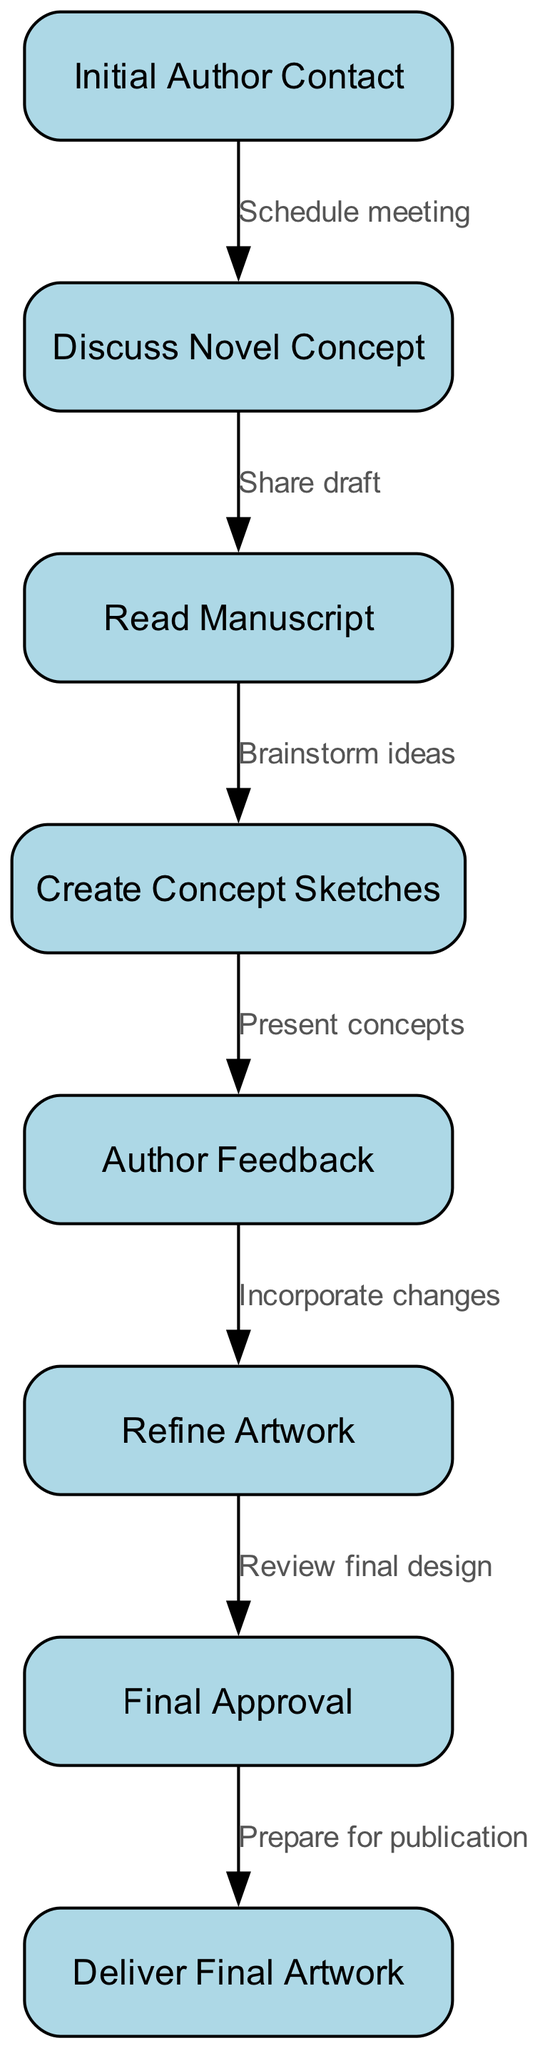What is the first step in the collaboration process? The first step in the collaboration process, as indicated by the initial node in the diagram, is "Initial Author Contact." This node does not have any preceding connections, confirming it as the starting point.
Answer: Initial Author Contact How many nodes are present in the diagram? By counting the distinct nodes listed in the data, we find there are 8 nodes illustrated in the collaboration process. Each one represents a unique step in the flowchart.
Answer: 8 What is the relationship between "Discuss Novel Concept" and "Read Manuscript"? The relationship is established by the directed edge from "Discuss Novel Concept" to "Read Manuscript," labeled as "Share draft." This indicates that the flow progresses from the discussion to sharing the manuscript for reading.
Answer: Share draft What action follows "Final Approval" in the process? The action that follows "Final Approval," as per the connection in the flowchart, is "Deliver Final Artwork." This sequential arrangement indicates the next step once approval has been secured.
Answer: Deliver Final Artwork Which two steps directly involve feedback? The two steps that involve feedback are "Author Feedback" and "Refine Artwork." The "Author Feedback" node solicits feedback, and "Refine Artwork" incorporates that feedback into revisions. Thus, both steps are interconnected through the feedback mechanism.
Answer: Author Feedback and Refine Artwork How many edges connect the nodes in the diagram? By reviewing the edges provided in the diagram data, there are 7 directed edges that connect the 8 nodes, demonstrating the flow from one step to another within the process.
Answer: 7 What step comes before "Create Concept Sketches"? The step immediately preceding "Create Concept Sketches," according to the directed flow, is "Read Manuscript." This showcases the logical progression from reading to brainstorming and sketching concepts.
Answer: Read Manuscript What is the last step in the collaboration process? The last step in the collaboration process is "Deliver Final Artwork," as it is the final node in the flowchart and represents the culmination of the collaborative effort.
Answer: Deliver Final Artwork 